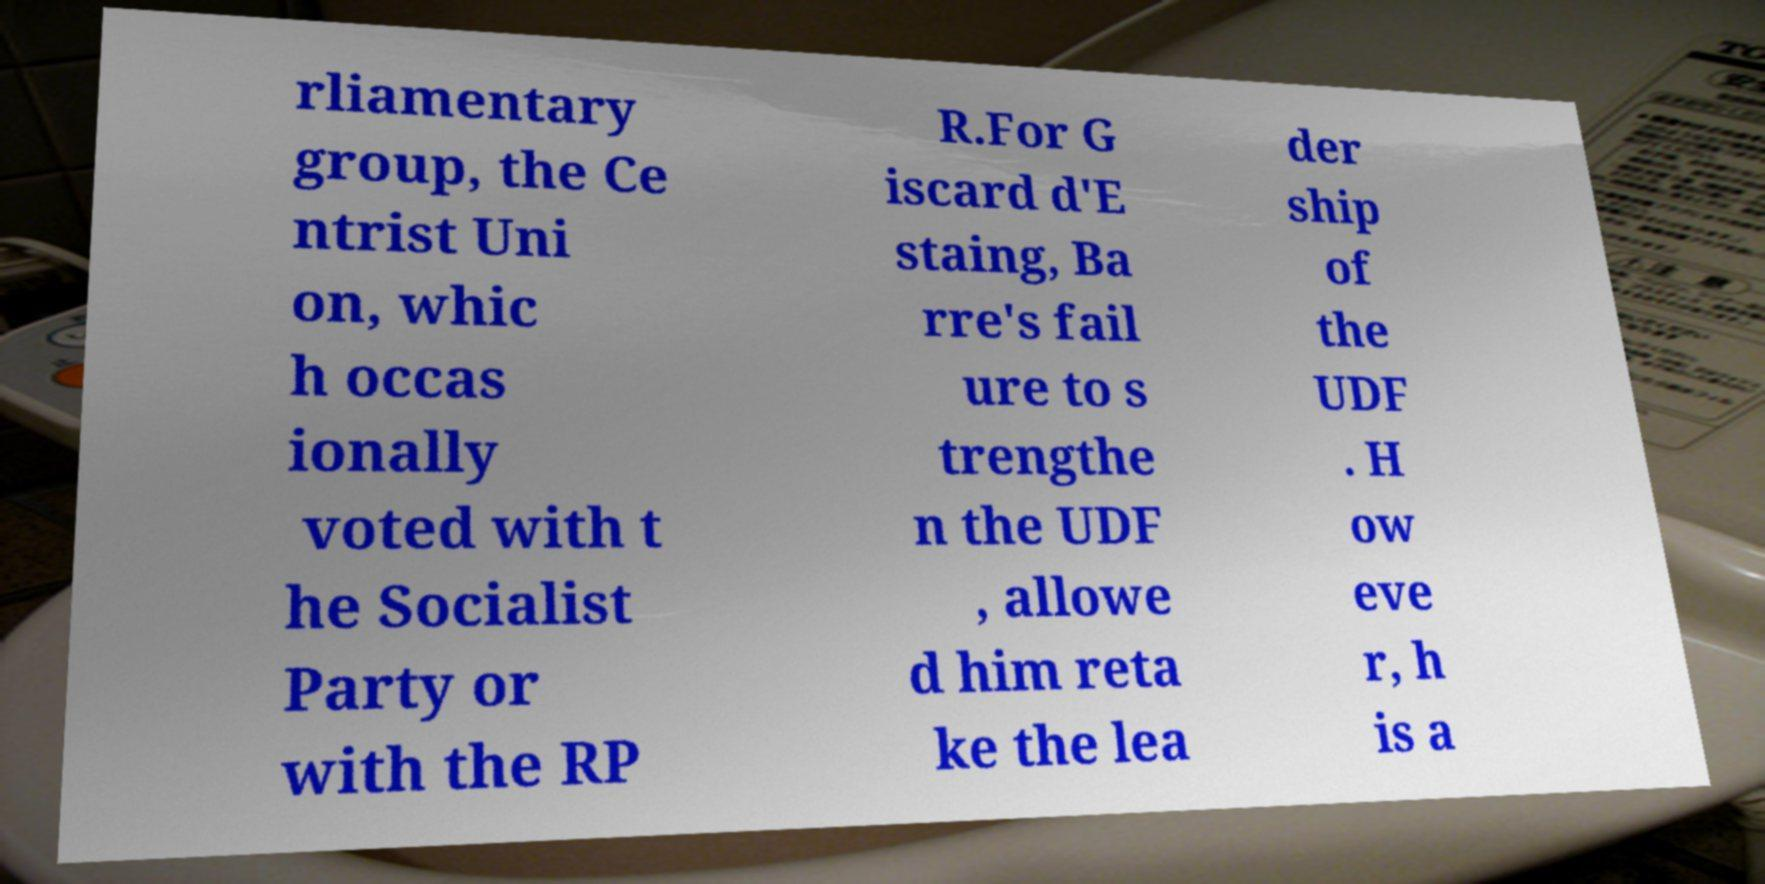Could you assist in decoding the text presented in this image and type it out clearly? rliamentary group, the Ce ntrist Uni on, whic h occas ionally voted with t he Socialist Party or with the RP R.For G iscard d'E staing, Ba rre's fail ure to s trengthe n the UDF , allowe d him reta ke the lea der ship of the UDF . H ow eve r, h is a 